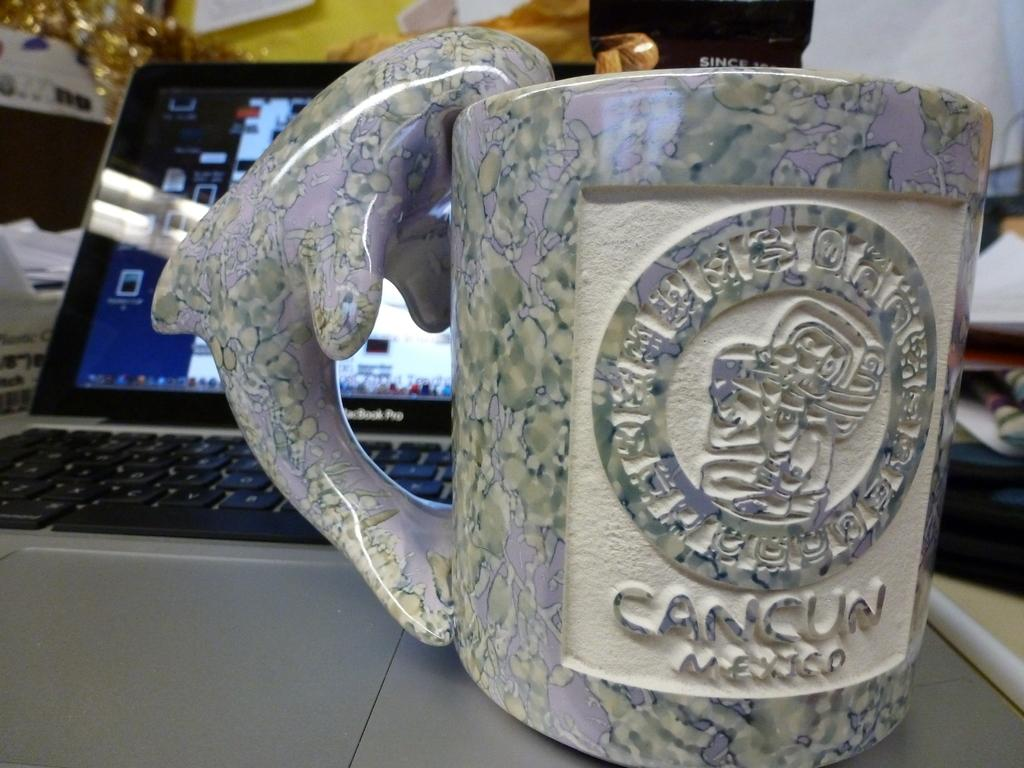<image>
Describe the image concisely. A souvenir mug from Cancun Mexico that has a dolphin handle 